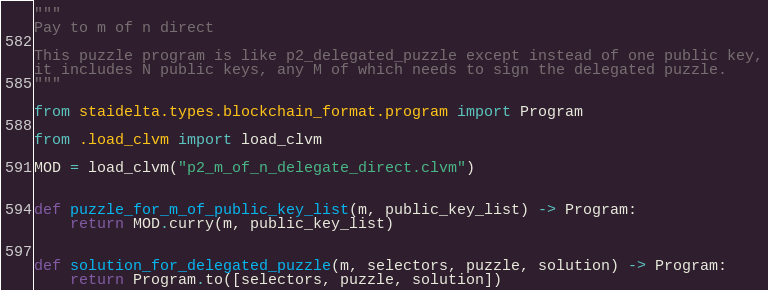<code> <loc_0><loc_0><loc_500><loc_500><_Python_>"""
Pay to m of n direct

This puzzle program is like p2_delegated_puzzle except instead of one public key,
it includes N public keys, any M of which needs to sign the delegated puzzle.
"""

from staidelta.types.blockchain_format.program import Program

from .load_clvm import load_clvm

MOD = load_clvm("p2_m_of_n_delegate_direct.clvm")


def puzzle_for_m_of_public_key_list(m, public_key_list) -> Program:
    return MOD.curry(m, public_key_list)


def solution_for_delegated_puzzle(m, selectors, puzzle, solution) -> Program:
    return Program.to([selectors, puzzle, solution])
</code> 